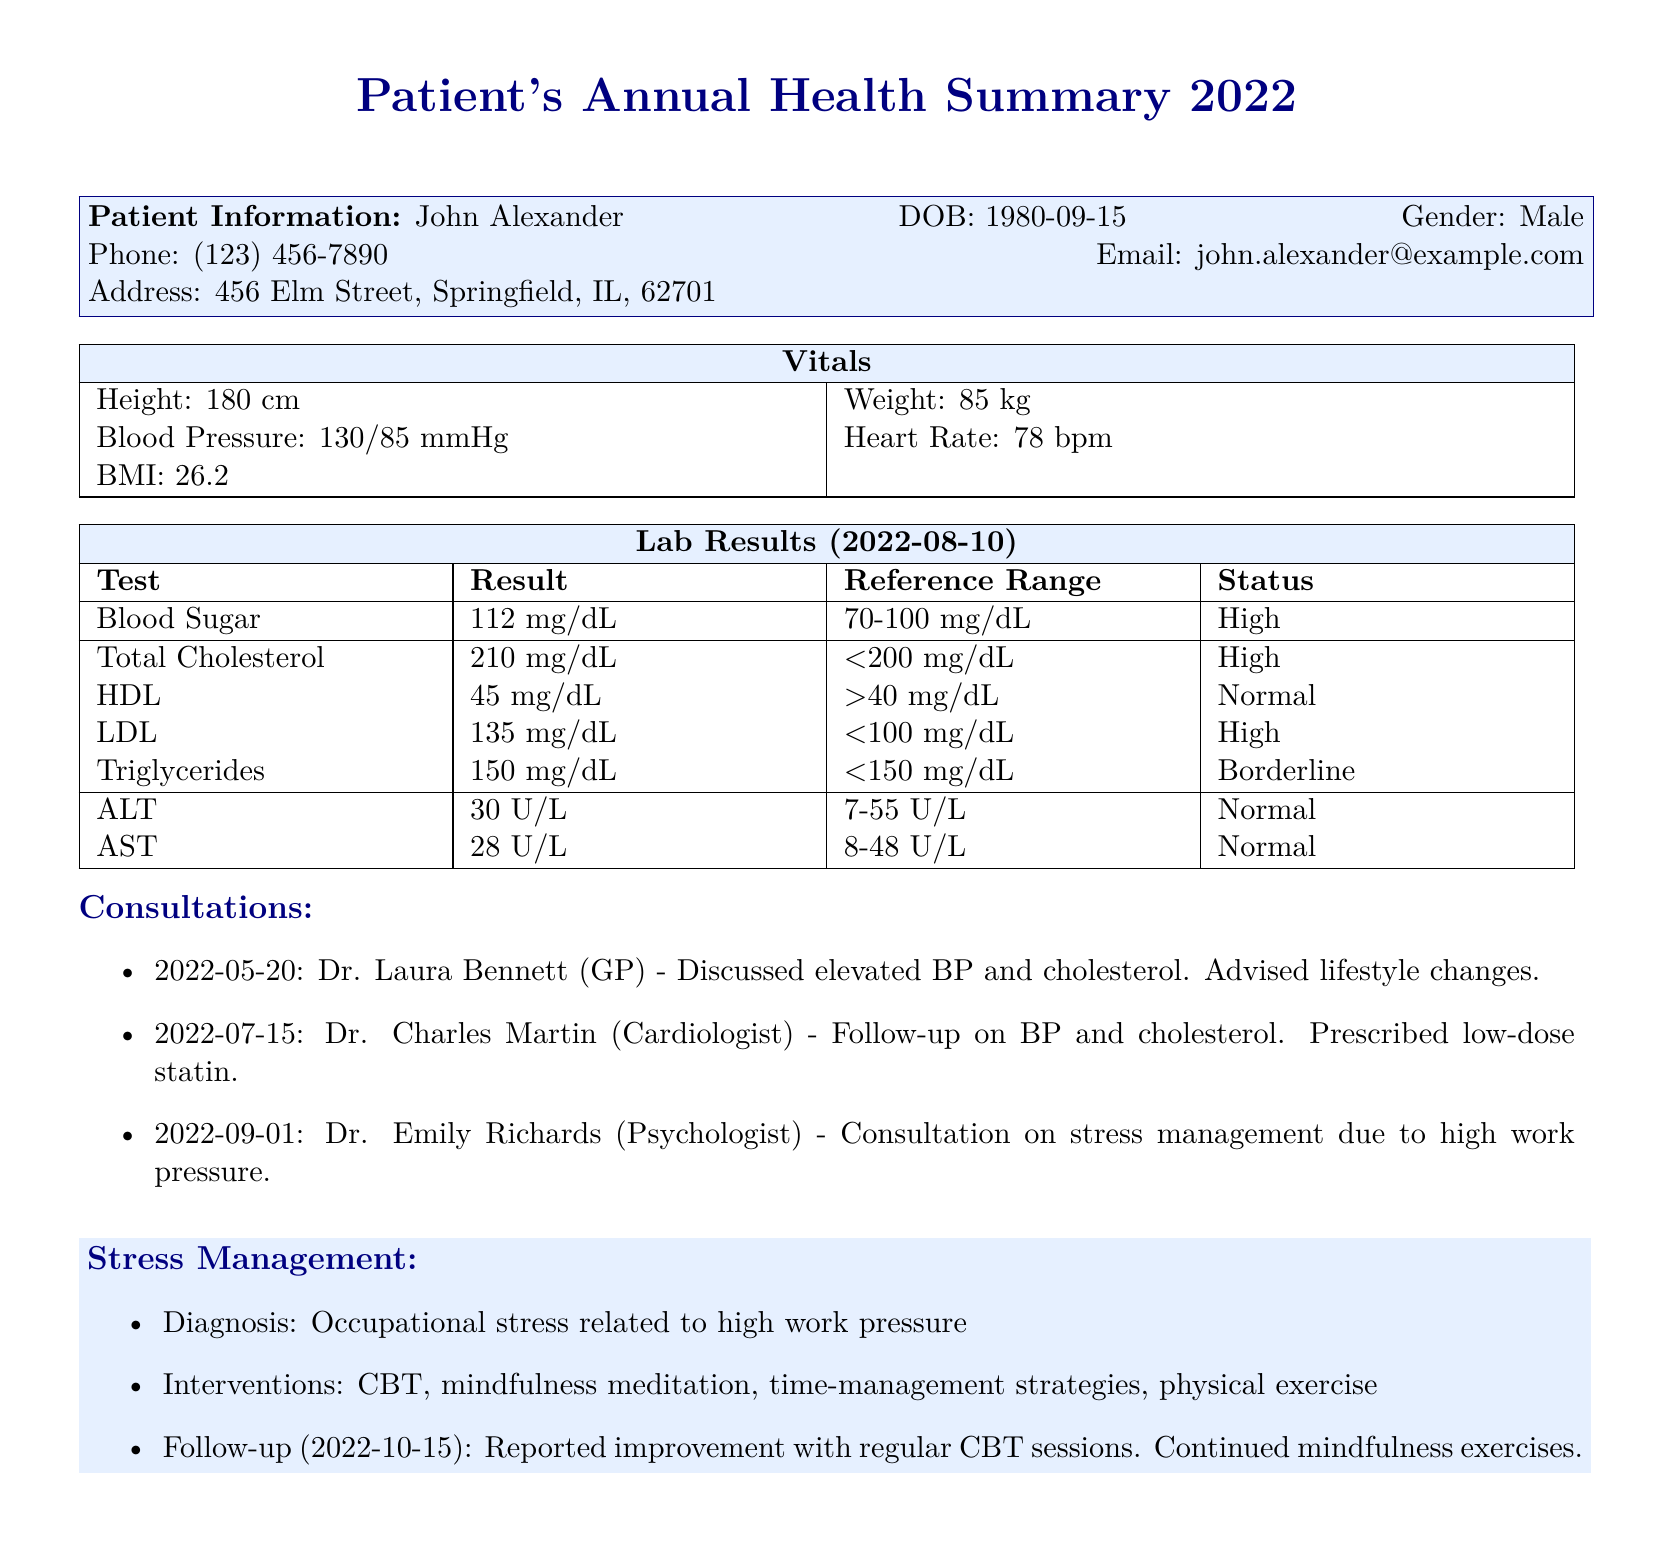What is the patient's name? The patient's name is mentioned at the top of the document under patient information.
Answer: John Alexander What is the patient's date of birth? The date of birth can be found in the patient information section of the document.
Answer: 1980-09-15 What is the patient's blood pressure reading? The blood pressure is listed under the vitals section of the document.
Answer: 130/85 mmHg What was the result of the total cholesterol test? The total cholesterol result is specified in the lab results table.
Answer: 210 mg/dL What consultation was related to stress management? The consultations listed show which doctor was consulted for stress management.
Answer: Dr. Emily Richards What intervention was reported for stress management improvement? The document details the interventions used in the stress management consultation.
Answer: CBT What was the follow-up date for the stress management consultation? The follow-up date is recorded in the stress management section of the document.
Answer: 2022-10-15 What was the patient's height? The patient's height is provided within the vitals section.
Answer: 180 cm Which lab result was marked as "High"? The lab result status indicates which test results were high, found in the lab results table.
Answer: Blood Sugar 